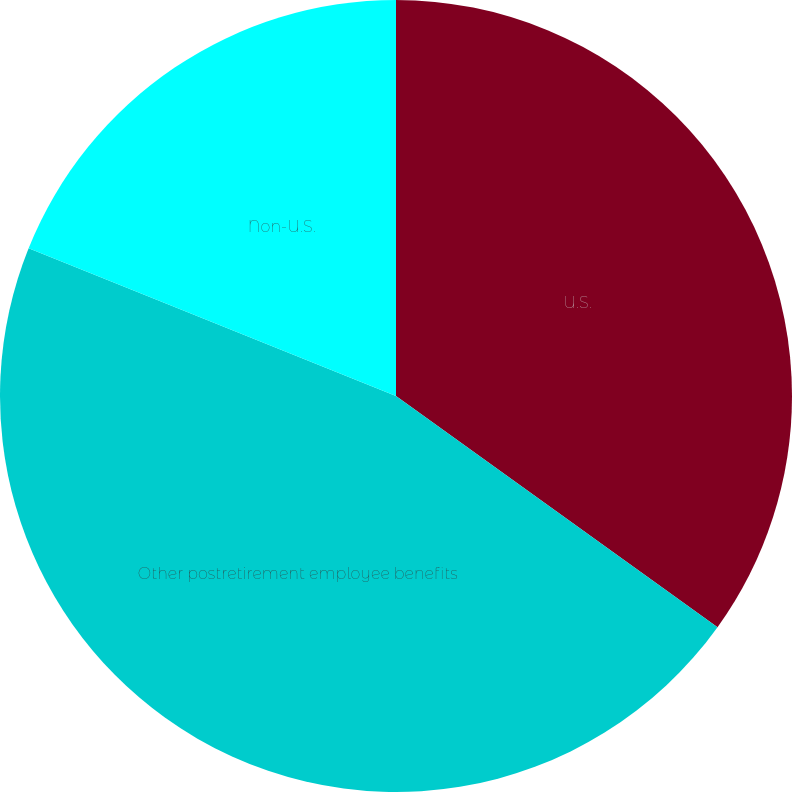Convert chart. <chart><loc_0><loc_0><loc_500><loc_500><pie_chart><fcel>U.S.<fcel>Other postretirement employee benefits<fcel>Non-U.S.<nl><fcel>34.92%<fcel>46.17%<fcel>18.91%<nl></chart> 